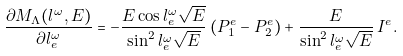Convert formula to latex. <formula><loc_0><loc_0><loc_500><loc_500>\frac { \partial M _ { \Lambda } ( l ^ { \omega } , E ) } { \partial l ^ { \omega } _ { e } } = - \frac { E \cos l ^ { \omega } _ { e } \sqrt { E } } { \sin ^ { 2 } l ^ { \omega } _ { e } \sqrt { E } } \, ( P _ { 1 } ^ { e } - P _ { 2 } ^ { e } ) + \frac { E } { \sin ^ { 2 } l ^ { \omega } _ { e } \sqrt { E } } \, I ^ { e } .</formula> 